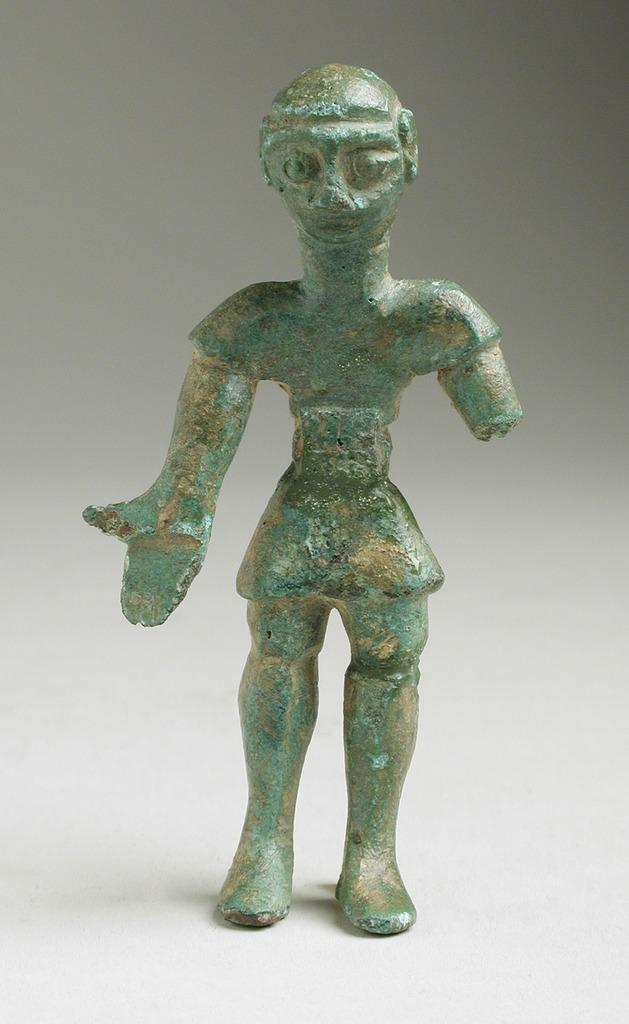What is the main subject of the image? There is a green color sculpture in the image. What color is the sculpture? The sculpture is green. What is the background color in the image? The background of the image is white. What type of argument is taking place between the zinc and the ticket in the image? There is no zinc or ticket present in the image, so no such argument can be observed. 